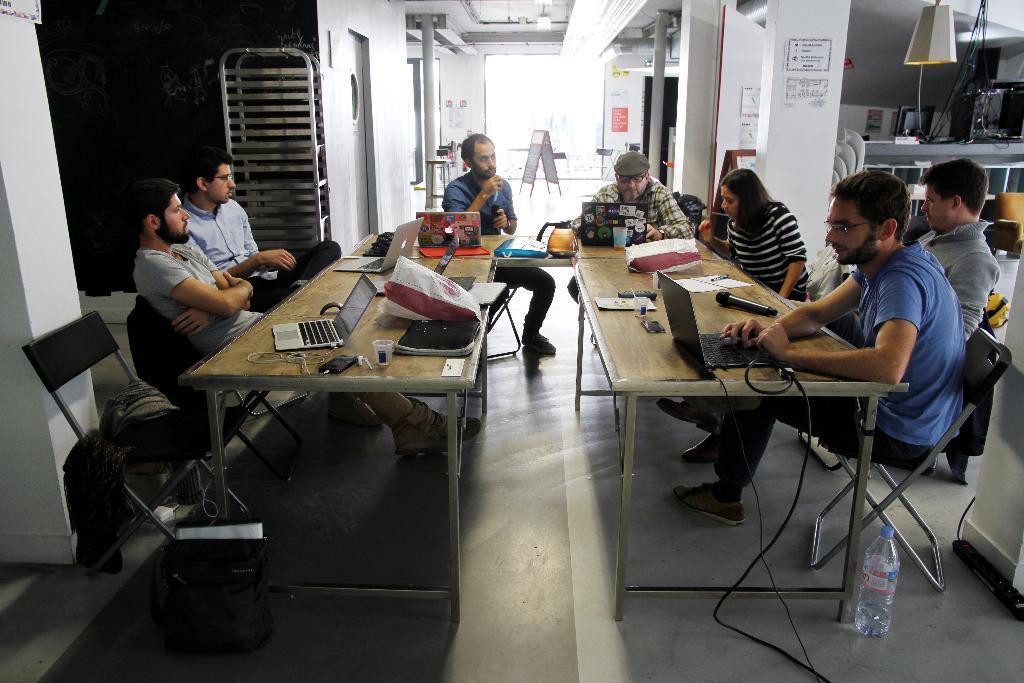Could you give a brief overview of what you see in this image? In the image we can see there are people sitting, wearing clothes, shoes and some of them are wearing spectacles. We can see there are chairs and tables. On the table we can see laptops, glass, cable wires, papers and other things. We can see there is even a bottle, light, glass window, pole, pillar and the floor. 